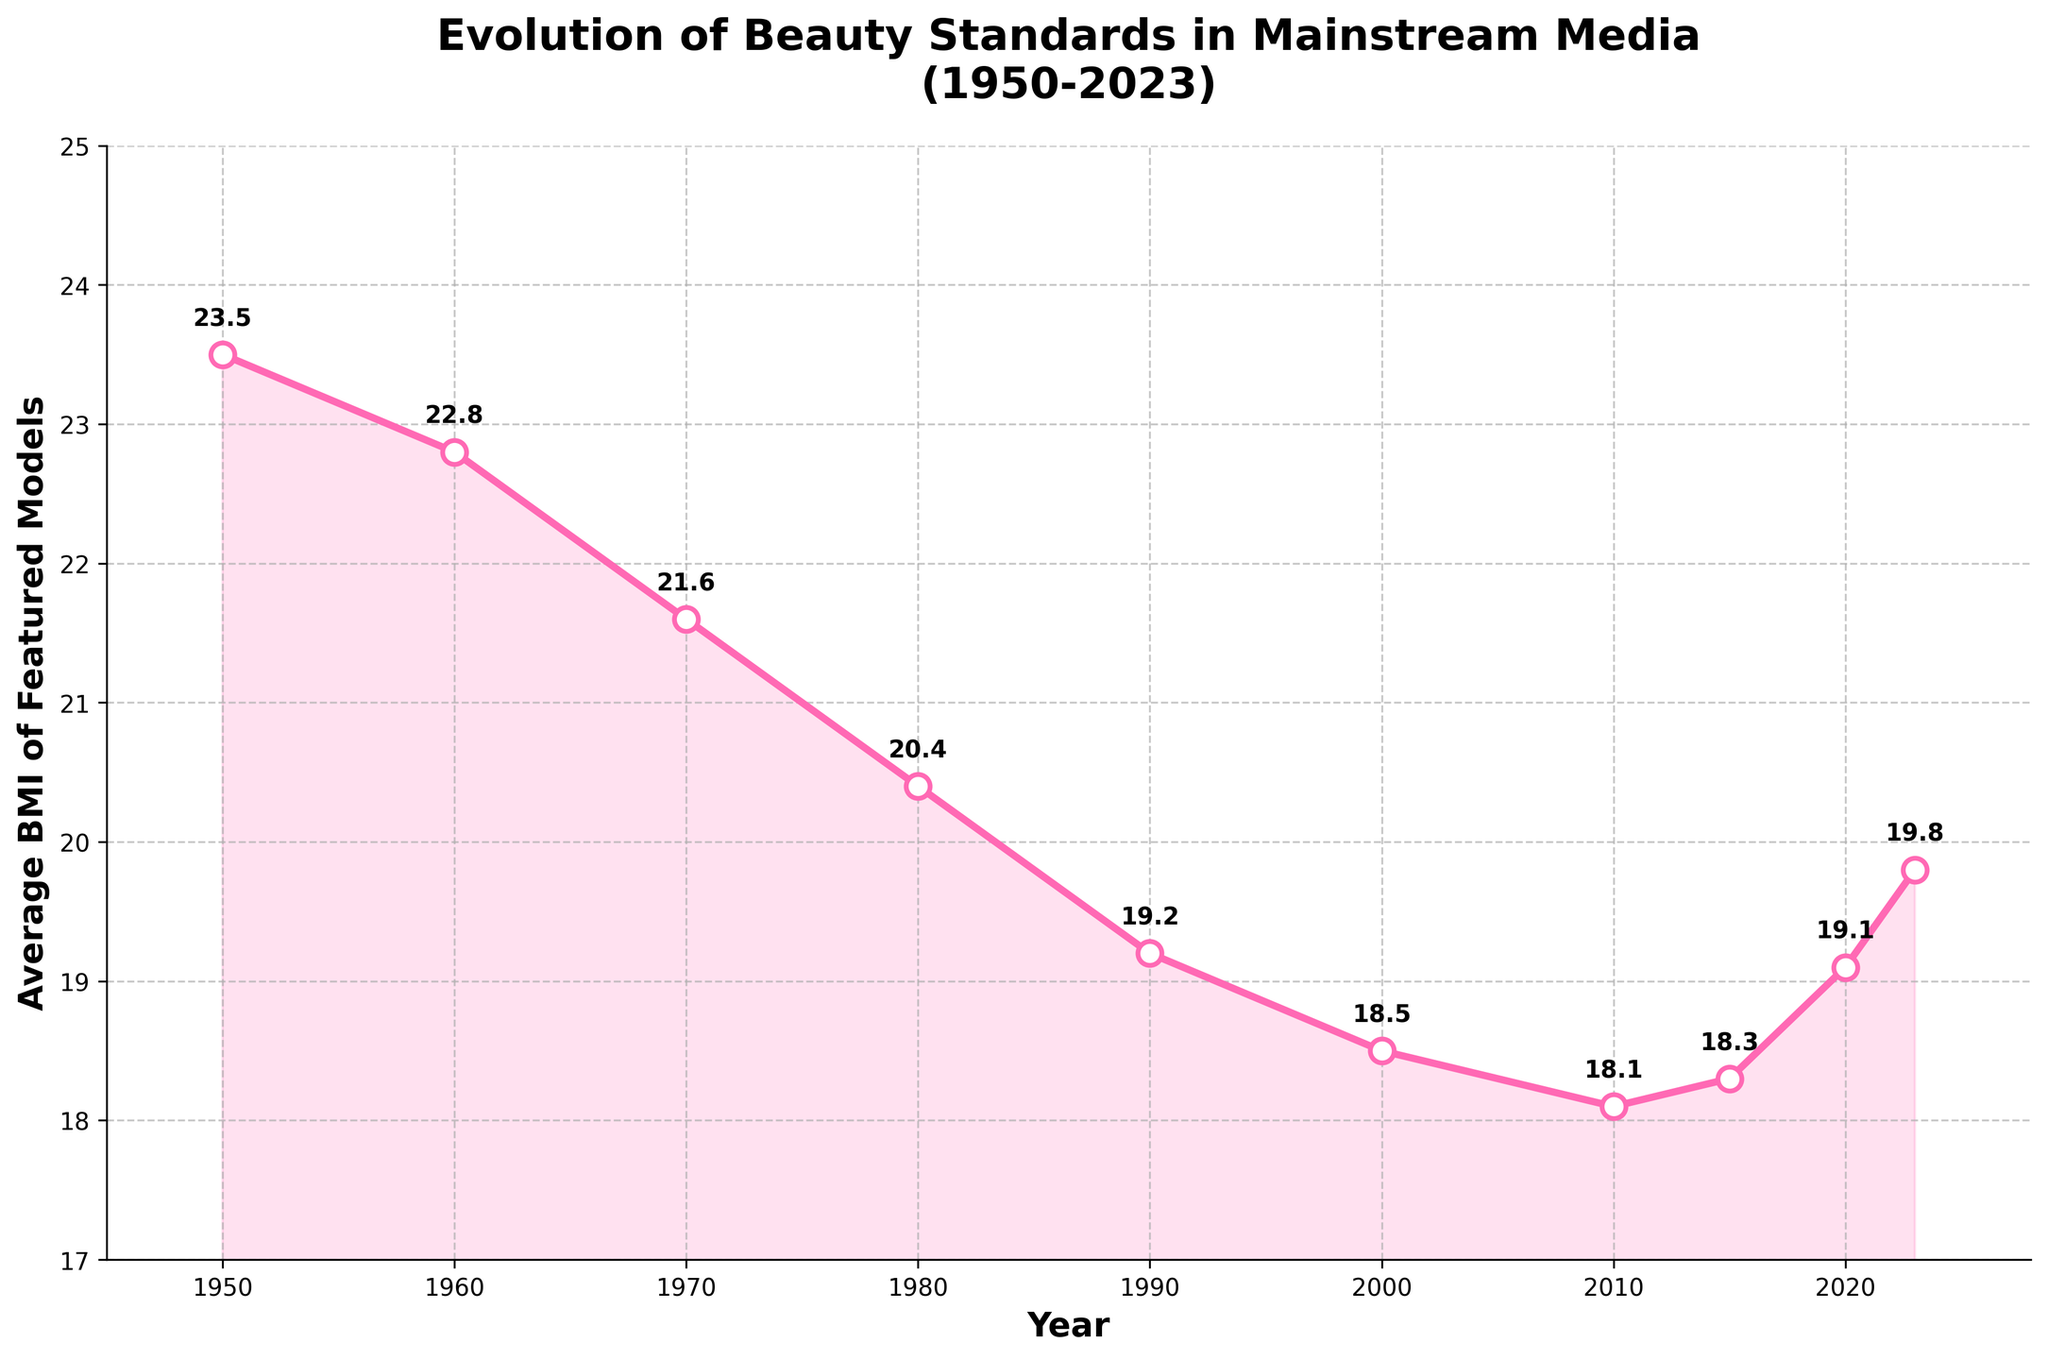What is the general trend of the average BMI of featured models from 1950 to 2023? Observe the line chart which shows a noticeable decline with minor fluctuations. The BMI starts at 23.5 in 1950 and drops to 18.1 by 2010 before slightly increasing to 19.8 by 2023.
Answer: Declining trend In which decade did the average BMI decline the most significantly? Look for the steepest slope in the line chart, which appears between 1980 and 1990 where the BMI drops from 20.4 to 19.2.
Answer: 1980s What is the difference in average BMI values between the highest and lowest points? Identify the highest point at 23.5 in 1950 and the lowest at 18.1 in 2010, then subtract to get the difference, 23.5 - 18.1 = 5.4.
Answer: 5.4 Between which years did the average BMI see an upward trend after a period of decline? After the decline noticed from 1950 to 2010, observe an upward trend from 2010 (BMI 18.1) to 2023 (BMI 19.8).
Answer: 2010 to 2023 Which year had the closest average BMI to 20? Scan for the data point nearest to 20, which happens in 1980 with an average BMI of 20.4.
Answer: 1980 What is the average BMI of featured models in the 21st century so far (2000 - 2023)? Sum the BMI values for 2000, 2010, 2015, 2020, and 2023 which are 18.5, 18.1, 18.3, 19.1, 19.8 and then divide by 5: (18.5 + 18.1 + 18.3 + 19.1 + 19.8) / 5 = 18.76.
Answer: 18.76 How does the average BMI in 2010 compare to that in 2000? Analyze the line chart for the data points 2000 (BMI 18.5) and 2010 (BMI 18.1), noting that 2010 is lower.
Answer: Lower in 2010 Was there any year between 1950 and 2023 where the BMI remained constant in successive years? Observe the points and their annual progression, recognizing that BMI values change every year; thus, there wasn’t a constant value in successive years.
Answer: No Which decade had the least change in average BMI? Compare the changes in average BMI for each decade. Between 2010 and 2020, the BMI changes from 18.1 to 19.1, a difference of 1.0, which is less fluctuating.
Answer: 2010s What pattern can be observed from the annotations on the chart? Notice that each data point is annotated with its respective BMI value, highlighting the changes and specific values are easier to see.
Answer: Displays specific BMI values 